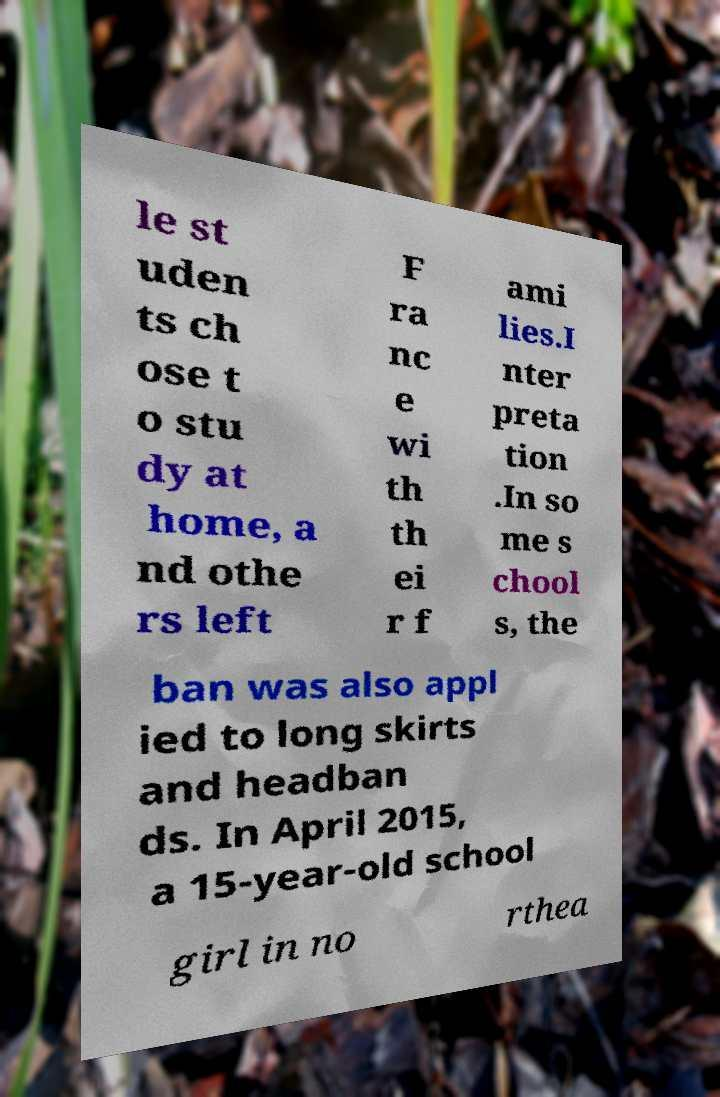Please identify and transcribe the text found in this image. le st uden ts ch ose t o stu dy at home, a nd othe rs left F ra nc e wi th th ei r f ami lies.I nter preta tion .In so me s chool s, the ban was also appl ied to long skirts and headban ds. In April 2015, a 15-year-old school girl in no rthea 